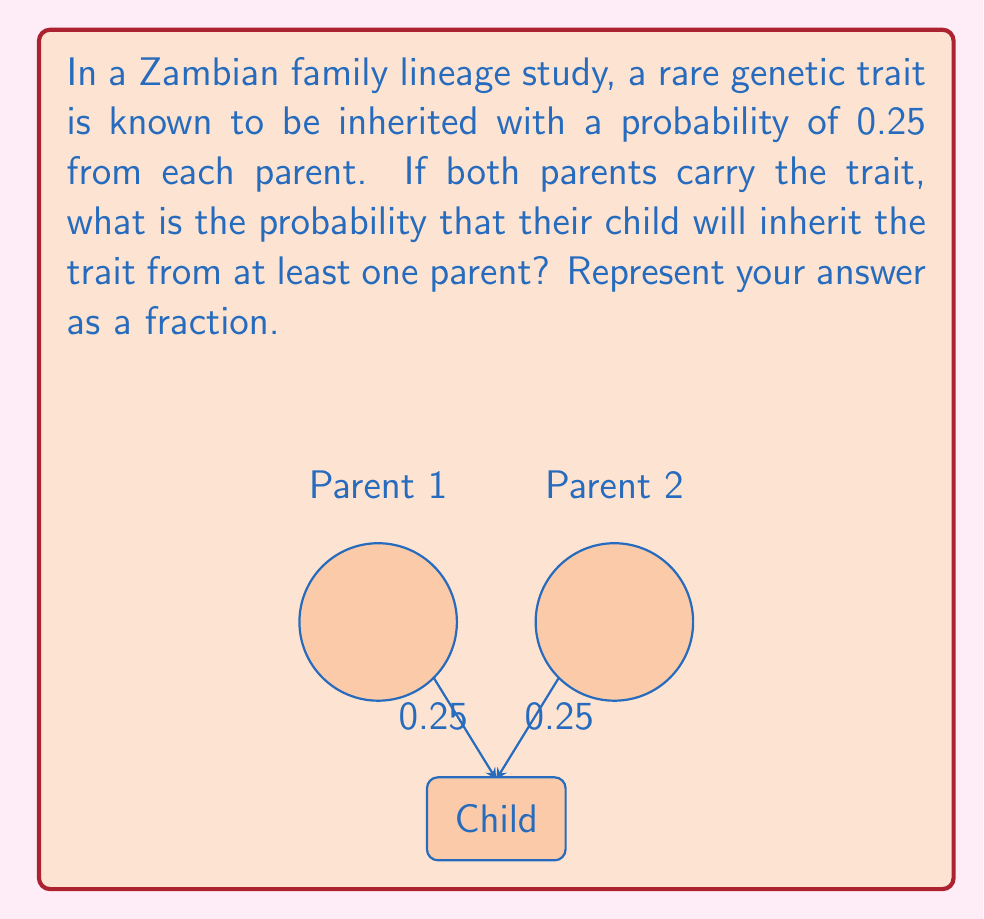Give your solution to this math problem. Let's approach this step-by-step:

1) The probability of inheriting the trait from a single parent is 0.25.

2) We need to find the probability of inheriting the trait from at least one parent. This is equivalent to 1 minus the probability of not inheriting the trait from either parent.

3) The probability of not inheriting the trait from a single parent is:
   $1 - 0.25 = 0.75$

4) For the child to not inherit the trait, they must not inherit it from either parent. These are independent events, so we multiply the probabilities:
   $0.75 * 0.75 = 0.5625$

5) Therefore, the probability of inheriting the trait from at least one parent is:
   $1 - 0.5625 = 0.4375$

6) This can be expressed as a fraction:
   $\frac{7}{16}$

To verify:
$$\frac{7}{16} = 0.4375$$
Answer: $\frac{7}{16}$ 